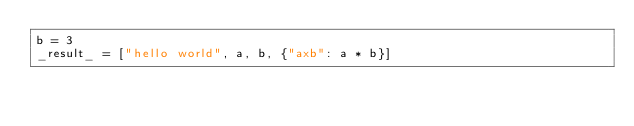<code> <loc_0><loc_0><loc_500><loc_500><_Python_>b = 3
_result_ = ["hello world", a, b, {"axb": a * b}]
</code> 